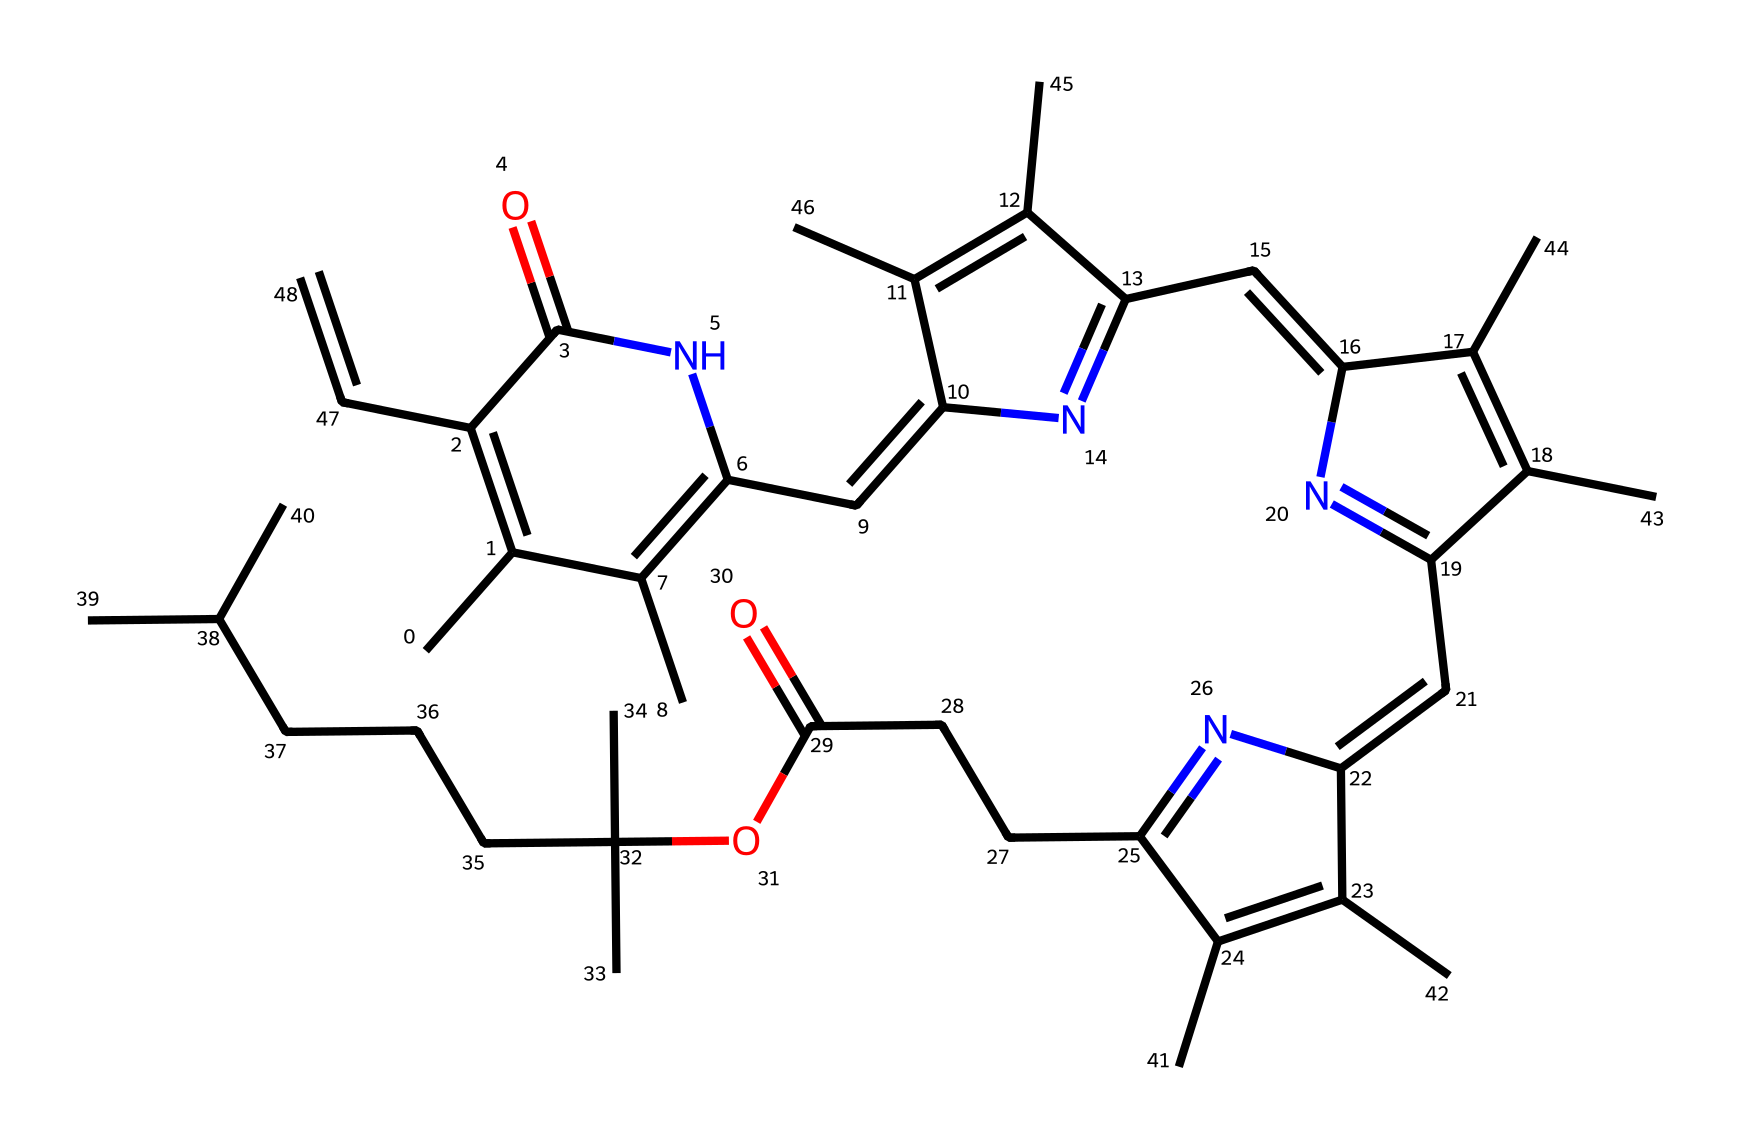What is the name of the central component in the structure of chlorophyll? The central component is a porphyrin ring, which is evident from the interconnected carbon atoms forming a cyclic structure with nitrogen atoms attached.
Answer: porphyrin ring How many carbon atoms are present in this chlorophyll structure? By analyzing the SMILES representation, I can count the carbon symbols 'C' and find a total of 37 carbon atoms in the structure.
Answer: 37 What type of bonds are primarily found in chlorophyll based on its structure? The structure shows multiple double bonds between the carbon atoms and also features nitrogen to carbon bonding, indicating a presence of both covalent double bonds and other strong covalent bonds.
Answer: covalent bonds Which heteroatom is present in the molecular composition of chlorophyll? The presence of 'N' in the SMILES indicates nitrogen as the heteroatom, which is crucial for the function of chlorophyll.
Answer: nitrogen What kind of functional groups are likely influencing water solubility in chlorophyll? The structure suggests the presence of ester functional groups due to the -OC notation found within the carbon chain, which can affect solubility in polar solvents like water.
Answer: ester groups How does the presence of nitrogen contribute to the functionality of chlorophyll? The nitrogen atoms participate in forming the porphyrin structure which is critical for capturing light energy, enhancing the compound's photosensitivity.
Answer: captures light 